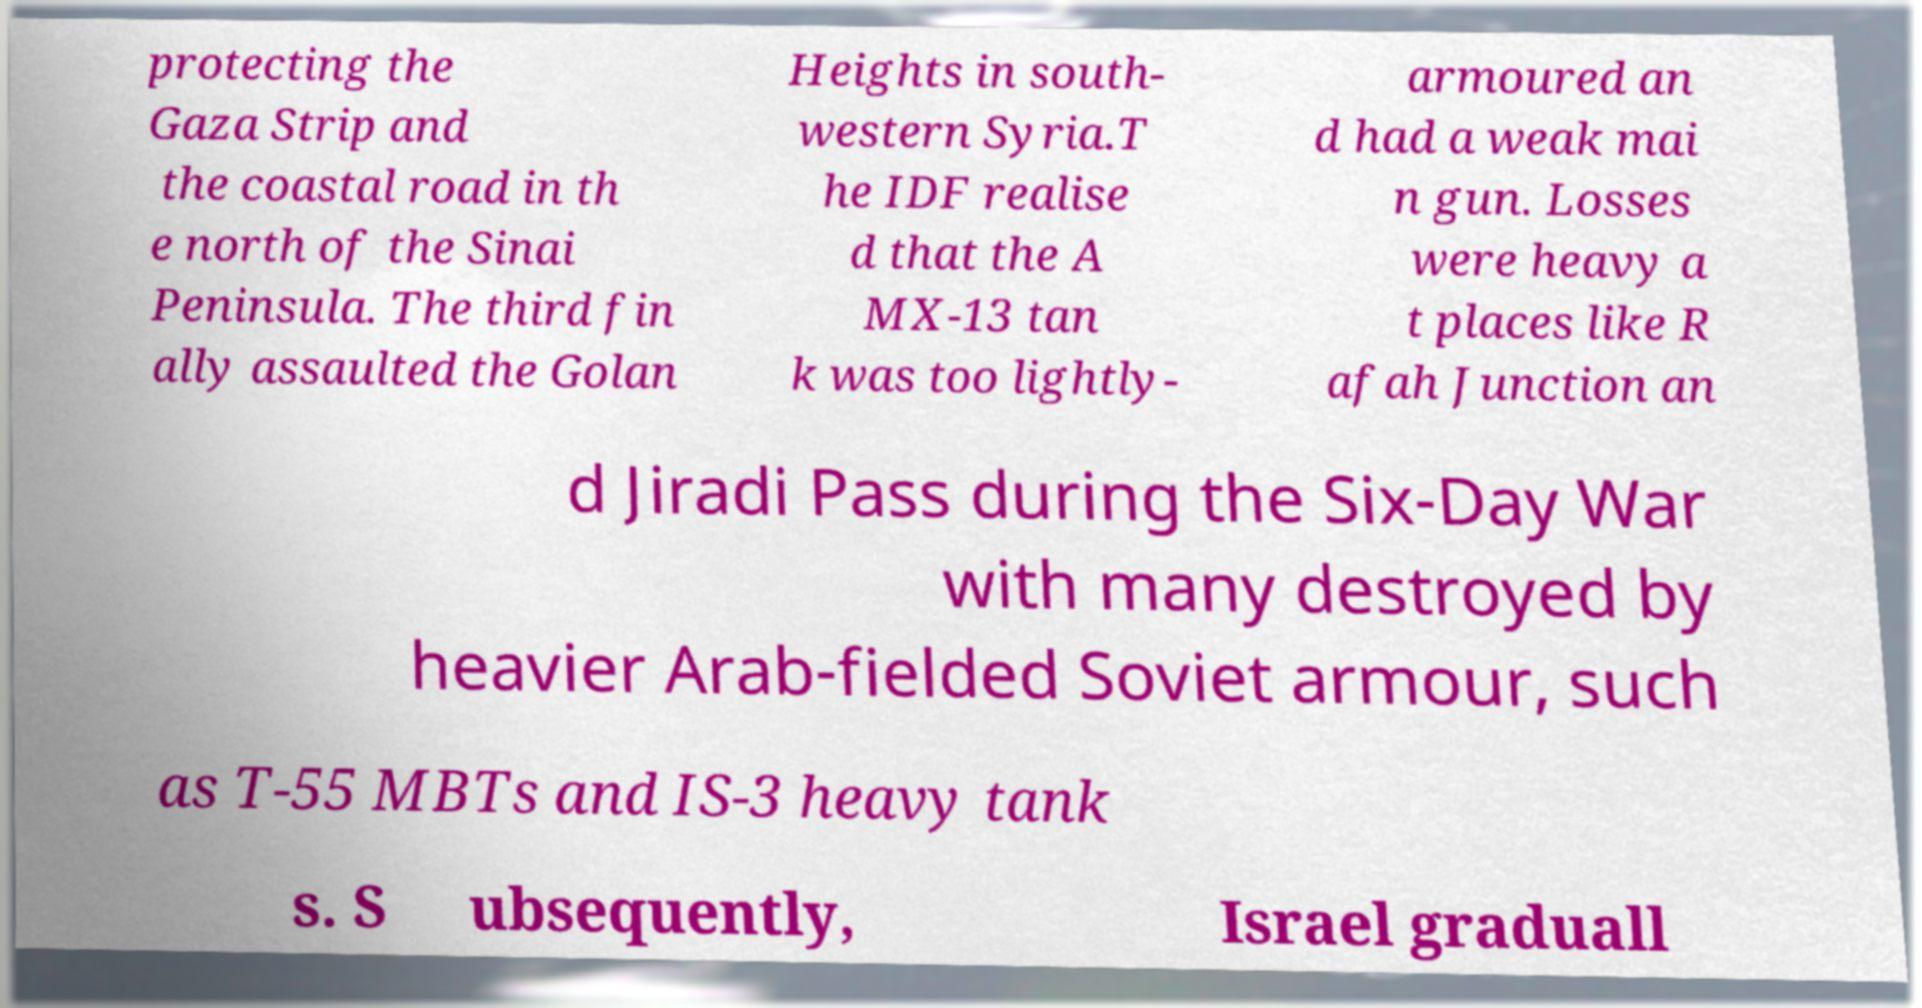Can you read and provide the text displayed in the image?This photo seems to have some interesting text. Can you extract and type it out for me? protecting the Gaza Strip and the coastal road in th e north of the Sinai Peninsula. The third fin ally assaulted the Golan Heights in south- western Syria.T he IDF realise d that the A MX-13 tan k was too lightly- armoured an d had a weak mai n gun. Losses were heavy a t places like R afah Junction an d Jiradi Pass during the Six-Day War with many destroyed by heavier Arab-fielded Soviet armour, such as T-55 MBTs and IS-3 heavy tank s. S ubsequently, Israel graduall 